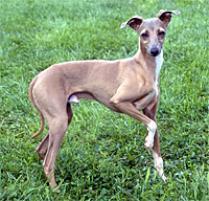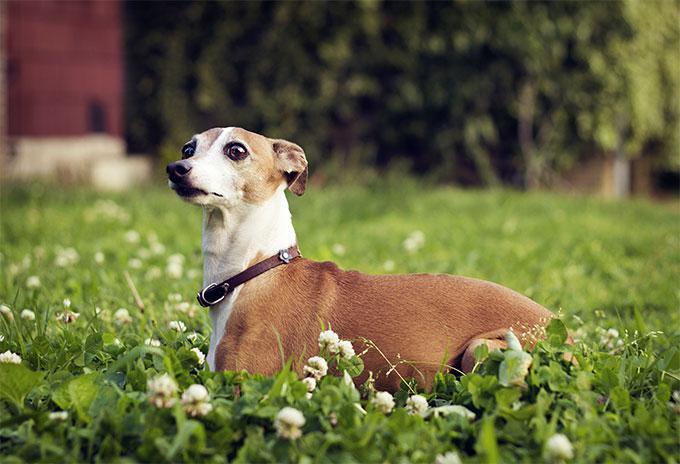The first image is the image on the left, the second image is the image on the right. Evaluate the accuracy of this statement regarding the images: "The dog in the left image is wearing a collar.". Is it true? Answer yes or no. No. The first image is the image on the left, the second image is the image on the right. For the images displayed, is the sentence "Each dog is posed outside with its head facing forward, and each dog wears a type of collar." factually correct? Answer yes or no. No. 